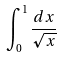<formula> <loc_0><loc_0><loc_500><loc_500>\int _ { 0 } ^ { 1 } \frac { d x } { \sqrt { x } }</formula> 